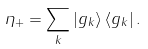Convert formula to latex. <formula><loc_0><loc_0><loc_500><loc_500>\eta _ { + } = \sum _ { k } \left | g _ { k } \right \rangle \left \langle g _ { k } \right | .</formula> 